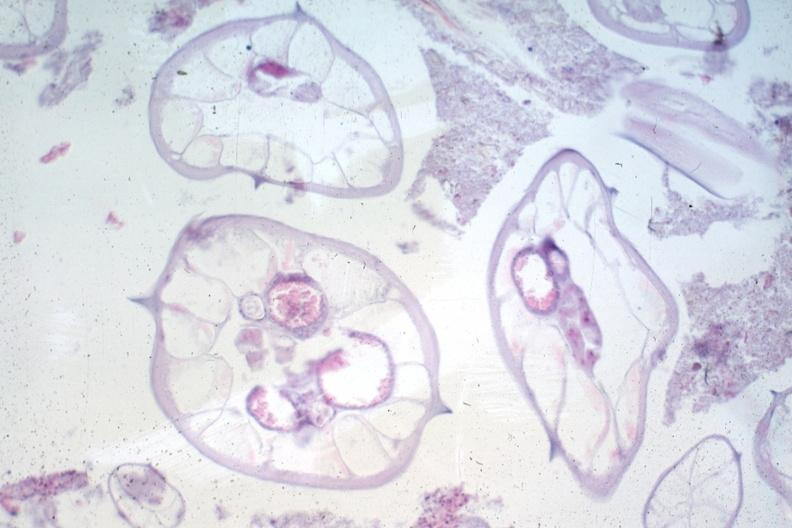s pinworm present?
Answer the question using a single word or phrase. Yes 